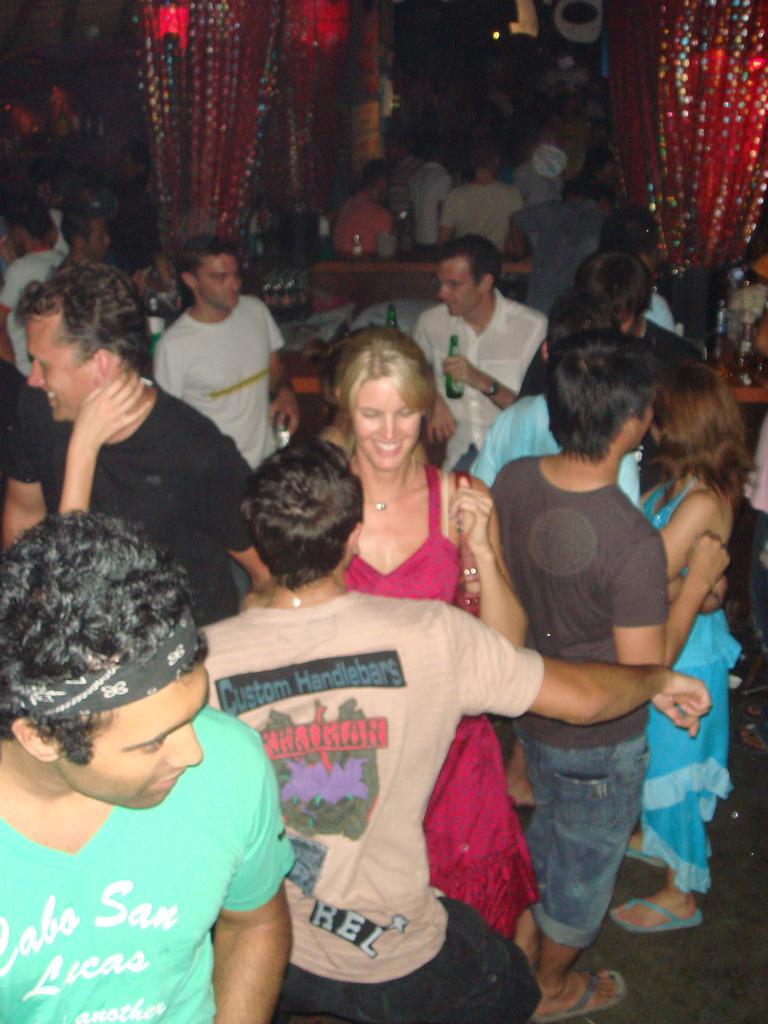Can you describe this image briefly? In this picture we can see a group of people where some are standing on the floor and smiling and in the background we can see red curtains. 